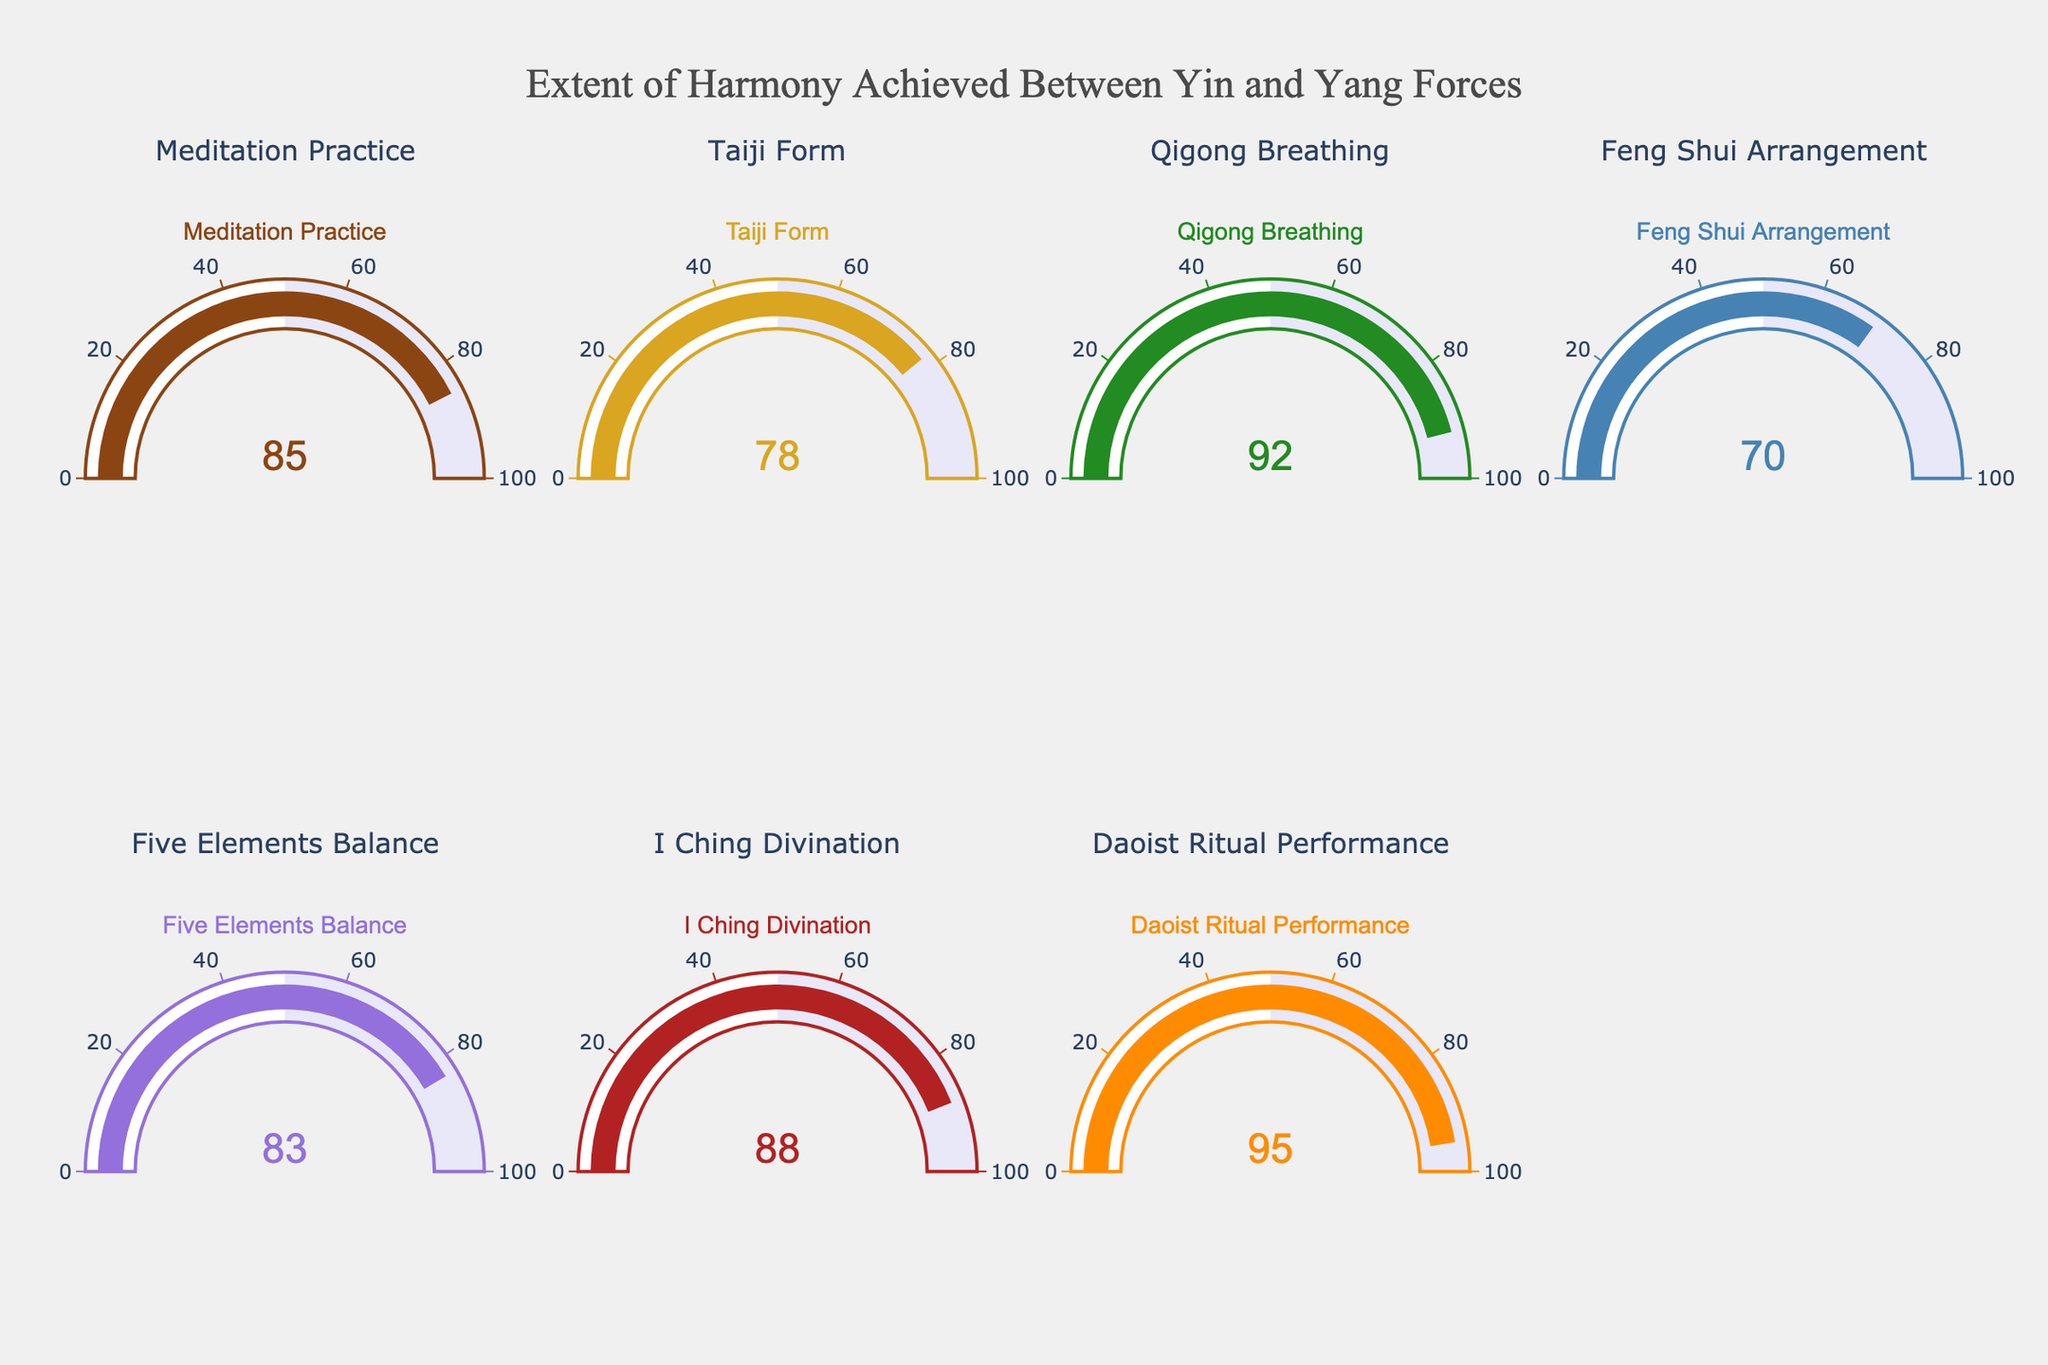What is the harmony score for Meditation Practice? To find the harmony score for Meditation Practice, look at the gauge corresponding to Meditation Practice. The gauge shows a value of 85.
Answer: 85 Which aspect has the highest harmony score? To identify the aspect with the highest harmony score, compare all the values displayed on each gauge. Daoist Ritual Performance at 95 is the highest.
Answer: Daoist Ritual Performance What is the average harmony score of all aspects? Sum all the scores: 85 (Meditation Practice) + 78 (Taiji Form) + 92 (Qigong Breathing) + 70 (Feng Shui Arrangement) + 83 (Five Elements Balance) + 88 (I Ching Divination) + 95 (Daoist Ritual Performance) = 591. There are 7 aspects, so the average is 591 / 7 = 84.43.
Answer: 84.43 How much higher is the harmony score of Qigong Breathing compared to Feng Shui Arrangement? The harmony score for Qigong Breathing is 92 and for Feng Shui Arrangement is 70. The difference is 92 - 70 = 22.
Answer: 22 Which aspect has the lowest harmony score? To find the aspect with the lowest harmony score, compare all the values displayed on each gauge. Feng Shui Arrangement at 70 is the lowest.
Answer: Feng Shui Arrangement Are there any aspects with a harmony score above 90? Examine the gauges to see which ones have scores above 90. Qigong Breathing (92) and Daoist Ritual Performance (95) have scores above 90.
Answer: Yes How does the score of Taiji Form compare to Five Elements Balance? The harmony score of Taiji Form is 78 and Five Elements Balance is 83. Taiji Form's score is lower than Five Elements Balance’s.
Answer: Lower What is the total harmony score for all aspects? Sum all the scores: 85 (Meditation Practice) + 78 (Taiji Form) + 92 (Qigong Breathing) + 70 (Feng Shui Arrangement) + 83 (Five Elements Balance) + 88 (I Ching Divination) + 95 (Daoist Ritual Performance). The total is 591.
Answer: 591 Which aspect has a harmony score closest to 80? Compare the scores to 80: Meditation Practice (85), Taiji Form (78), Qigong Breathing (92), Feng Shui Arrangement (70), Five Elements Balance (83), I Ching Divination (88), and Daoist Ritual Performance (95). Taiji Form at 78 is closest to 80.
Answer: Taiji Form 